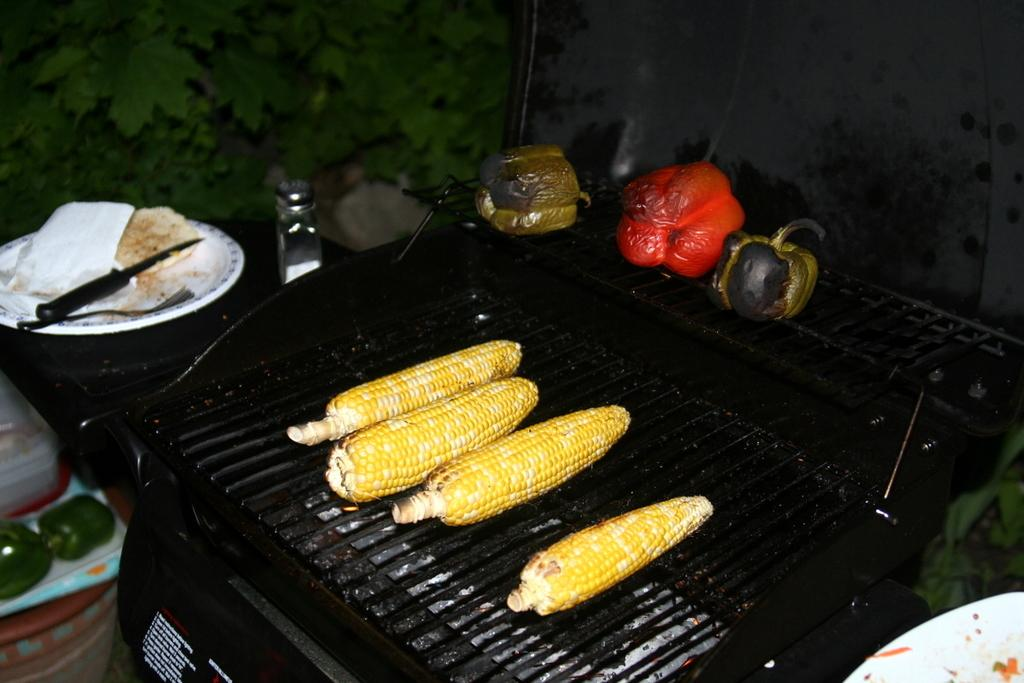What is being cooked on the grills in the image? Maize and bell peppers are being cooked on the grills in the image. What type of food can be seen on a plate in the image? There is a plate with food in the image, but the specific type of food is not mentioned in the facts. What utensils are present in the image? There is a knife and a fork in the image. What type of paper is present in the image? The facts do not specify the type of paper in the image. What type of container is present in the image? There is a jar and a box in the image. What type of vegetation is present in the image? There are vegetable leaves and green bell peppers in the image. What other objects can be seen in the image? The facts mention that there are other objects in the image, but they do not specify what they are. How many toes can be seen in the image? There are no toes visible in the image. What type of sugar is being used to sweeten the food in the image? The facts do not mention any sugar being used in the image. 